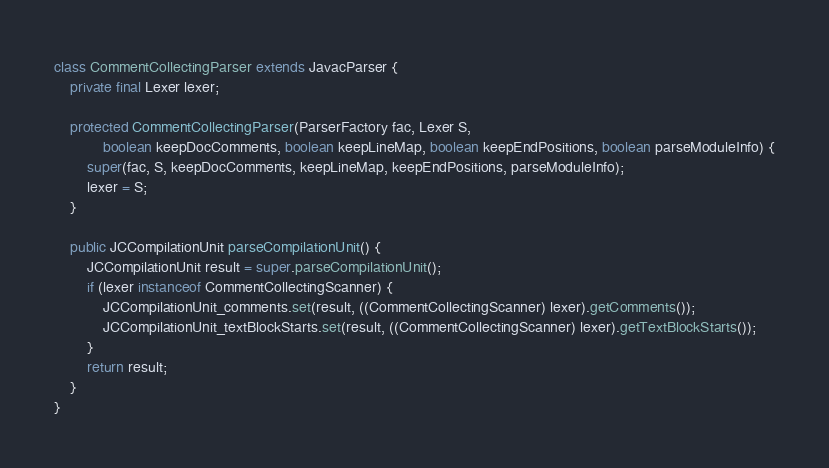Convert code to text. <code><loc_0><loc_0><loc_500><loc_500><_Java_>
class CommentCollectingParser extends JavacParser {
	private final Lexer lexer;
	
	protected CommentCollectingParser(ParserFactory fac, Lexer S,
			boolean keepDocComments, boolean keepLineMap, boolean keepEndPositions, boolean parseModuleInfo) {
		super(fac, S, keepDocComments, keepLineMap, keepEndPositions, parseModuleInfo);
		lexer = S;
	}
	
	public JCCompilationUnit parseCompilationUnit() {
		JCCompilationUnit result = super.parseCompilationUnit();
		if (lexer instanceof CommentCollectingScanner) {
			JCCompilationUnit_comments.set(result, ((CommentCollectingScanner) lexer).getComments());
			JCCompilationUnit_textBlockStarts.set(result, ((CommentCollectingScanner) lexer).getTextBlockStarts());
		}
		return result;
	}
}</code> 